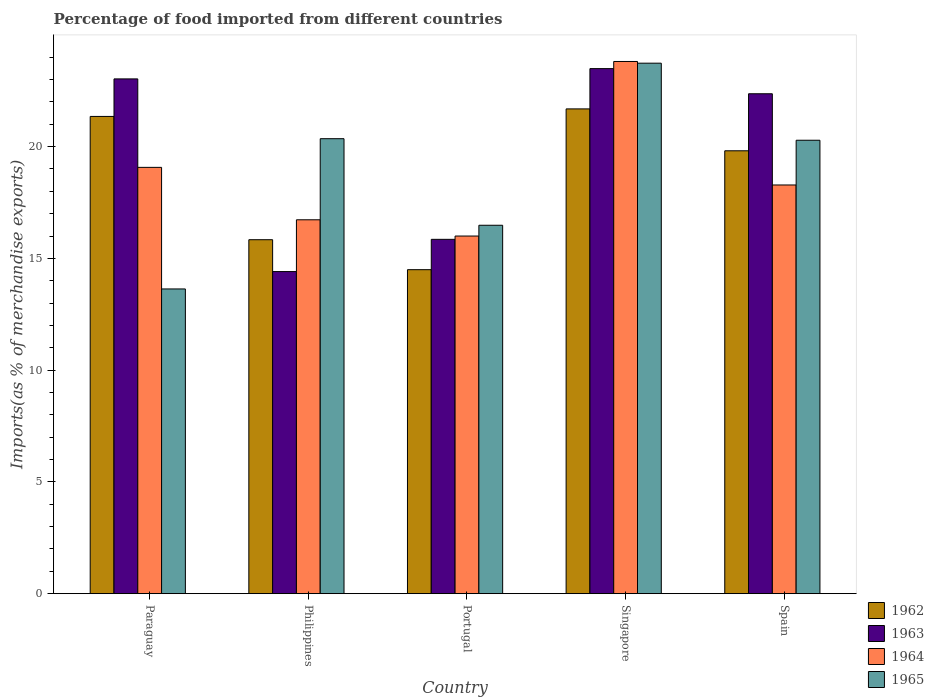How many different coloured bars are there?
Your response must be concise. 4. Are the number of bars on each tick of the X-axis equal?
Your response must be concise. Yes. How many bars are there on the 4th tick from the right?
Provide a short and direct response. 4. What is the label of the 1st group of bars from the left?
Keep it short and to the point. Paraguay. In how many cases, is the number of bars for a given country not equal to the number of legend labels?
Make the answer very short. 0. What is the percentage of imports to different countries in 1964 in Singapore?
Keep it short and to the point. 23.81. Across all countries, what is the maximum percentage of imports to different countries in 1964?
Provide a short and direct response. 23.81. Across all countries, what is the minimum percentage of imports to different countries in 1963?
Offer a terse response. 14.41. In which country was the percentage of imports to different countries in 1963 maximum?
Your answer should be compact. Singapore. In which country was the percentage of imports to different countries in 1965 minimum?
Your answer should be very brief. Paraguay. What is the total percentage of imports to different countries in 1963 in the graph?
Your answer should be compact. 99.14. What is the difference between the percentage of imports to different countries in 1963 in Philippines and that in Spain?
Provide a succinct answer. -7.96. What is the difference between the percentage of imports to different countries in 1964 in Portugal and the percentage of imports to different countries in 1965 in Philippines?
Make the answer very short. -4.36. What is the average percentage of imports to different countries in 1963 per country?
Your answer should be very brief. 19.83. What is the difference between the percentage of imports to different countries of/in 1964 and percentage of imports to different countries of/in 1963 in Paraguay?
Make the answer very short. -3.96. What is the ratio of the percentage of imports to different countries in 1965 in Paraguay to that in Portugal?
Keep it short and to the point. 0.83. What is the difference between the highest and the second highest percentage of imports to different countries in 1963?
Your answer should be very brief. 0.66. What is the difference between the highest and the lowest percentage of imports to different countries in 1963?
Your response must be concise. 9.08. What does the 1st bar from the left in Philippines represents?
Your answer should be very brief. 1962. What does the 4th bar from the right in Portugal represents?
Provide a short and direct response. 1962. Is it the case that in every country, the sum of the percentage of imports to different countries in 1963 and percentage of imports to different countries in 1965 is greater than the percentage of imports to different countries in 1964?
Provide a short and direct response. Yes. Are all the bars in the graph horizontal?
Provide a succinct answer. No. How many countries are there in the graph?
Your answer should be very brief. 5. Does the graph contain grids?
Offer a terse response. No. How many legend labels are there?
Make the answer very short. 4. What is the title of the graph?
Give a very brief answer. Percentage of food imported from different countries. What is the label or title of the Y-axis?
Provide a succinct answer. Imports(as % of merchandise exports). What is the Imports(as % of merchandise exports) in 1962 in Paraguay?
Provide a short and direct response. 21.35. What is the Imports(as % of merchandise exports) in 1963 in Paraguay?
Offer a very short reply. 23.03. What is the Imports(as % of merchandise exports) of 1964 in Paraguay?
Offer a terse response. 19.07. What is the Imports(as % of merchandise exports) in 1965 in Paraguay?
Provide a succinct answer. 13.63. What is the Imports(as % of merchandise exports) in 1962 in Philippines?
Your answer should be very brief. 15.83. What is the Imports(as % of merchandise exports) in 1963 in Philippines?
Offer a very short reply. 14.41. What is the Imports(as % of merchandise exports) of 1964 in Philippines?
Ensure brevity in your answer.  16.73. What is the Imports(as % of merchandise exports) of 1965 in Philippines?
Give a very brief answer. 20.35. What is the Imports(as % of merchandise exports) of 1962 in Portugal?
Provide a short and direct response. 14.49. What is the Imports(as % of merchandise exports) of 1963 in Portugal?
Give a very brief answer. 15.85. What is the Imports(as % of merchandise exports) of 1964 in Portugal?
Ensure brevity in your answer.  16. What is the Imports(as % of merchandise exports) in 1965 in Portugal?
Offer a terse response. 16.48. What is the Imports(as % of merchandise exports) of 1962 in Singapore?
Provide a succinct answer. 21.69. What is the Imports(as % of merchandise exports) of 1963 in Singapore?
Make the answer very short. 23.49. What is the Imports(as % of merchandise exports) in 1964 in Singapore?
Offer a terse response. 23.81. What is the Imports(as % of merchandise exports) of 1965 in Singapore?
Give a very brief answer. 23.73. What is the Imports(as % of merchandise exports) of 1962 in Spain?
Offer a terse response. 19.81. What is the Imports(as % of merchandise exports) in 1963 in Spain?
Provide a short and direct response. 22.36. What is the Imports(as % of merchandise exports) in 1964 in Spain?
Offer a very short reply. 18.28. What is the Imports(as % of merchandise exports) in 1965 in Spain?
Provide a short and direct response. 20.28. Across all countries, what is the maximum Imports(as % of merchandise exports) of 1962?
Offer a very short reply. 21.69. Across all countries, what is the maximum Imports(as % of merchandise exports) of 1963?
Make the answer very short. 23.49. Across all countries, what is the maximum Imports(as % of merchandise exports) of 1964?
Provide a succinct answer. 23.81. Across all countries, what is the maximum Imports(as % of merchandise exports) of 1965?
Make the answer very short. 23.73. Across all countries, what is the minimum Imports(as % of merchandise exports) in 1962?
Offer a terse response. 14.49. Across all countries, what is the minimum Imports(as % of merchandise exports) in 1963?
Offer a very short reply. 14.41. Across all countries, what is the minimum Imports(as % of merchandise exports) in 1964?
Ensure brevity in your answer.  16. Across all countries, what is the minimum Imports(as % of merchandise exports) of 1965?
Provide a short and direct response. 13.63. What is the total Imports(as % of merchandise exports) in 1962 in the graph?
Your answer should be very brief. 93.18. What is the total Imports(as % of merchandise exports) in 1963 in the graph?
Ensure brevity in your answer.  99.14. What is the total Imports(as % of merchandise exports) of 1964 in the graph?
Your answer should be compact. 93.89. What is the total Imports(as % of merchandise exports) of 1965 in the graph?
Your response must be concise. 94.48. What is the difference between the Imports(as % of merchandise exports) of 1962 in Paraguay and that in Philippines?
Ensure brevity in your answer.  5.52. What is the difference between the Imports(as % of merchandise exports) in 1963 in Paraguay and that in Philippines?
Give a very brief answer. 8.62. What is the difference between the Imports(as % of merchandise exports) in 1964 in Paraguay and that in Philippines?
Provide a succinct answer. 2.35. What is the difference between the Imports(as % of merchandise exports) of 1965 in Paraguay and that in Philippines?
Provide a succinct answer. -6.72. What is the difference between the Imports(as % of merchandise exports) of 1962 in Paraguay and that in Portugal?
Provide a succinct answer. 6.86. What is the difference between the Imports(as % of merchandise exports) of 1963 in Paraguay and that in Portugal?
Offer a very short reply. 7.18. What is the difference between the Imports(as % of merchandise exports) of 1964 in Paraguay and that in Portugal?
Offer a very short reply. 3.07. What is the difference between the Imports(as % of merchandise exports) in 1965 in Paraguay and that in Portugal?
Your answer should be compact. -2.85. What is the difference between the Imports(as % of merchandise exports) in 1962 in Paraguay and that in Singapore?
Offer a very short reply. -0.34. What is the difference between the Imports(as % of merchandise exports) of 1963 in Paraguay and that in Singapore?
Keep it short and to the point. -0.46. What is the difference between the Imports(as % of merchandise exports) in 1964 in Paraguay and that in Singapore?
Your response must be concise. -4.74. What is the difference between the Imports(as % of merchandise exports) of 1965 in Paraguay and that in Singapore?
Give a very brief answer. -10.1. What is the difference between the Imports(as % of merchandise exports) of 1962 in Paraguay and that in Spain?
Offer a terse response. 1.54. What is the difference between the Imports(as % of merchandise exports) of 1963 in Paraguay and that in Spain?
Your response must be concise. 0.66. What is the difference between the Imports(as % of merchandise exports) of 1964 in Paraguay and that in Spain?
Ensure brevity in your answer.  0.79. What is the difference between the Imports(as % of merchandise exports) in 1965 in Paraguay and that in Spain?
Your answer should be very brief. -6.65. What is the difference between the Imports(as % of merchandise exports) in 1962 in Philippines and that in Portugal?
Your response must be concise. 1.34. What is the difference between the Imports(as % of merchandise exports) of 1963 in Philippines and that in Portugal?
Offer a terse response. -1.44. What is the difference between the Imports(as % of merchandise exports) in 1964 in Philippines and that in Portugal?
Give a very brief answer. 0.73. What is the difference between the Imports(as % of merchandise exports) of 1965 in Philippines and that in Portugal?
Give a very brief answer. 3.87. What is the difference between the Imports(as % of merchandise exports) in 1962 in Philippines and that in Singapore?
Provide a succinct answer. -5.85. What is the difference between the Imports(as % of merchandise exports) of 1963 in Philippines and that in Singapore?
Offer a very short reply. -9.08. What is the difference between the Imports(as % of merchandise exports) in 1964 in Philippines and that in Singapore?
Provide a succinct answer. -7.08. What is the difference between the Imports(as % of merchandise exports) of 1965 in Philippines and that in Singapore?
Offer a very short reply. -3.38. What is the difference between the Imports(as % of merchandise exports) of 1962 in Philippines and that in Spain?
Your answer should be very brief. -3.98. What is the difference between the Imports(as % of merchandise exports) of 1963 in Philippines and that in Spain?
Your answer should be compact. -7.96. What is the difference between the Imports(as % of merchandise exports) in 1964 in Philippines and that in Spain?
Offer a terse response. -1.56. What is the difference between the Imports(as % of merchandise exports) in 1965 in Philippines and that in Spain?
Provide a succinct answer. 0.07. What is the difference between the Imports(as % of merchandise exports) in 1962 in Portugal and that in Singapore?
Give a very brief answer. -7.19. What is the difference between the Imports(as % of merchandise exports) of 1963 in Portugal and that in Singapore?
Your response must be concise. -7.64. What is the difference between the Imports(as % of merchandise exports) of 1964 in Portugal and that in Singapore?
Offer a very short reply. -7.81. What is the difference between the Imports(as % of merchandise exports) in 1965 in Portugal and that in Singapore?
Provide a short and direct response. -7.25. What is the difference between the Imports(as % of merchandise exports) in 1962 in Portugal and that in Spain?
Provide a succinct answer. -5.32. What is the difference between the Imports(as % of merchandise exports) in 1963 in Portugal and that in Spain?
Offer a very short reply. -6.51. What is the difference between the Imports(as % of merchandise exports) of 1964 in Portugal and that in Spain?
Make the answer very short. -2.28. What is the difference between the Imports(as % of merchandise exports) of 1965 in Portugal and that in Spain?
Your response must be concise. -3.8. What is the difference between the Imports(as % of merchandise exports) of 1962 in Singapore and that in Spain?
Your response must be concise. 1.87. What is the difference between the Imports(as % of merchandise exports) of 1963 in Singapore and that in Spain?
Ensure brevity in your answer.  1.12. What is the difference between the Imports(as % of merchandise exports) in 1964 in Singapore and that in Spain?
Your response must be concise. 5.52. What is the difference between the Imports(as % of merchandise exports) of 1965 in Singapore and that in Spain?
Your response must be concise. 3.45. What is the difference between the Imports(as % of merchandise exports) in 1962 in Paraguay and the Imports(as % of merchandise exports) in 1963 in Philippines?
Offer a terse response. 6.94. What is the difference between the Imports(as % of merchandise exports) of 1962 in Paraguay and the Imports(as % of merchandise exports) of 1964 in Philippines?
Your answer should be compact. 4.62. What is the difference between the Imports(as % of merchandise exports) in 1962 in Paraguay and the Imports(as % of merchandise exports) in 1965 in Philippines?
Your answer should be compact. 1. What is the difference between the Imports(as % of merchandise exports) of 1963 in Paraguay and the Imports(as % of merchandise exports) of 1964 in Philippines?
Make the answer very short. 6.3. What is the difference between the Imports(as % of merchandise exports) in 1963 in Paraguay and the Imports(as % of merchandise exports) in 1965 in Philippines?
Your answer should be very brief. 2.67. What is the difference between the Imports(as % of merchandise exports) of 1964 in Paraguay and the Imports(as % of merchandise exports) of 1965 in Philippines?
Your answer should be compact. -1.28. What is the difference between the Imports(as % of merchandise exports) in 1962 in Paraguay and the Imports(as % of merchandise exports) in 1963 in Portugal?
Provide a short and direct response. 5.5. What is the difference between the Imports(as % of merchandise exports) of 1962 in Paraguay and the Imports(as % of merchandise exports) of 1964 in Portugal?
Your response must be concise. 5.35. What is the difference between the Imports(as % of merchandise exports) of 1962 in Paraguay and the Imports(as % of merchandise exports) of 1965 in Portugal?
Your response must be concise. 4.87. What is the difference between the Imports(as % of merchandise exports) in 1963 in Paraguay and the Imports(as % of merchandise exports) in 1964 in Portugal?
Your answer should be very brief. 7.03. What is the difference between the Imports(as % of merchandise exports) of 1963 in Paraguay and the Imports(as % of merchandise exports) of 1965 in Portugal?
Your answer should be compact. 6.55. What is the difference between the Imports(as % of merchandise exports) in 1964 in Paraguay and the Imports(as % of merchandise exports) in 1965 in Portugal?
Make the answer very short. 2.59. What is the difference between the Imports(as % of merchandise exports) in 1962 in Paraguay and the Imports(as % of merchandise exports) in 1963 in Singapore?
Your answer should be compact. -2.14. What is the difference between the Imports(as % of merchandise exports) in 1962 in Paraguay and the Imports(as % of merchandise exports) in 1964 in Singapore?
Your answer should be compact. -2.46. What is the difference between the Imports(as % of merchandise exports) in 1962 in Paraguay and the Imports(as % of merchandise exports) in 1965 in Singapore?
Your answer should be compact. -2.38. What is the difference between the Imports(as % of merchandise exports) in 1963 in Paraguay and the Imports(as % of merchandise exports) in 1964 in Singapore?
Give a very brief answer. -0.78. What is the difference between the Imports(as % of merchandise exports) in 1963 in Paraguay and the Imports(as % of merchandise exports) in 1965 in Singapore?
Provide a short and direct response. -0.7. What is the difference between the Imports(as % of merchandise exports) of 1964 in Paraguay and the Imports(as % of merchandise exports) of 1965 in Singapore?
Keep it short and to the point. -4.66. What is the difference between the Imports(as % of merchandise exports) in 1962 in Paraguay and the Imports(as % of merchandise exports) in 1963 in Spain?
Offer a very short reply. -1.01. What is the difference between the Imports(as % of merchandise exports) of 1962 in Paraguay and the Imports(as % of merchandise exports) of 1964 in Spain?
Offer a very short reply. 3.07. What is the difference between the Imports(as % of merchandise exports) in 1962 in Paraguay and the Imports(as % of merchandise exports) in 1965 in Spain?
Provide a short and direct response. 1.07. What is the difference between the Imports(as % of merchandise exports) in 1963 in Paraguay and the Imports(as % of merchandise exports) in 1964 in Spain?
Provide a succinct answer. 4.75. What is the difference between the Imports(as % of merchandise exports) of 1963 in Paraguay and the Imports(as % of merchandise exports) of 1965 in Spain?
Provide a short and direct response. 2.74. What is the difference between the Imports(as % of merchandise exports) in 1964 in Paraguay and the Imports(as % of merchandise exports) in 1965 in Spain?
Provide a succinct answer. -1.21. What is the difference between the Imports(as % of merchandise exports) in 1962 in Philippines and the Imports(as % of merchandise exports) in 1963 in Portugal?
Your response must be concise. -0.02. What is the difference between the Imports(as % of merchandise exports) of 1962 in Philippines and the Imports(as % of merchandise exports) of 1964 in Portugal?
Make the answer very short. -0.16. What is the difference between the Imports(as % of merchandise exports) in 1962 in Philippines and the Imports(as % of merchandise exports) in 1965 in Portugal?
Offer a very short reply. -0.65. What is the difference between the Imports(as % of merchandise exports) of 1963 in Philippines and the Imports(as % of merchandise exports) of 1964 in Portugal?
Offer a terse response. -1.59. What is the difference between the Imports(as % of merchandise exports) in 1963 in Philippines and the Imports(as % of merchandise exports) in 1965 in Portugal?
Keep it short and to the point. -2.07. What is the difference between the Imports(as % of merchandise exports) in 1964 in Philippines and the Imports(as % of merchandise exports) in 1965 in Portugal?
Your response must be concise. 0.24. What is the difference between the Imports(as % of merchandise exports) in 1962 in Philippines and the Imports(as % of merchandise exports) in 1963 in Singapore?
Make the answer very short. -7.65. What is the difference between the Imports(as % of merchandise exports) in 1962 in Philippines and the Imports(as % of merchandise exports) in 1964 in Singapore?
Your response must be concise. -7.97. What is the difference between the Imports(as % of merchandise exports) of 1962 in Philippines and the Imports(as % of merchandise exports) of 1965 in Singapore?
Offer a very short reply. -7.9. What is the difference between the Imports(as % of merchandise exports) of 1963 in Philippines and the Imports(as % of merchandise exports) of 1964 in Singapore?
Provide a short and direct response. -9.4. What is the difference between the Imports(as % of merchandise exports) in 1963 in Philippines and the Imports(as % of merchandise exports) in 1965 in Singapore?
Your response must be concise. -9.32. What is the difference between the Imports(as % of merchandise exports) of 1964 in Philippines and the Imports(as % of merchandise exports) of 1965 in Singapore?
Your answer should be compact. -7.01. What is the difference between the Imports(as % of merchandise exports) of 1962 in Philippines and the Imports(as % of merchandise exports) of 1963 in Spain?
Ensure brevity in your answer.  -6.53. What is the difference between the Imports(as % of merchandise exports) in 1962 in Philippines and the Imports(as % of merchandise exports) in 1964 in Spain?
Keep it short and to the point. -2.45. What is the difference between the Imports(as % of merchandise exports) in 1962 in Philippines and the Imports(as % of merchandise exports) in 1965 in Spain?
Offer a very short reply. -4.45. What is the difference between the Imports(as % of merchandise exports) of 1963 in Philippines and the Imports(as % of merchandise exports) of 1964 in Spain?
Your answer should be compact. -3.87. What is the difference between the Imports(as % of merchandise exports) in 1963 in Philippines and the Imports(as % of merchandise exports) in 1965 in Spain?
Keep it short and to the point. -5.88. What is the difference between the Imports(as % of merchandise exports) of 1964 in Philippines and the Imports(as % of merchandise exports) of 1965 in Spain?
Make the answer very short. -3.56. What is the difference between the Imports(as % of merchandise exports) in 1962 in Portugal and the Imports(as % of merchandise exports) in 1963 in Singapore?
Offer a very short reply. -8.99. What is the difference between the Imports(as % of merchandise exports) in 1962 in Portugal and the Imports(as % of merchandise exports) in 1964 in Singapore?
Provide a short and direct response. -9.31. What is the difference between the Imports(as % of merchandise exports) of 1962 in Portugal and the Imports(as % of merchandise exports) of 1965 in Singapore?
Keep it short and to the point. -9.24. What is the difference between the Imports(as % of merchandise exports) in 1963 in Portugal and the Imports(as % of merchandise exports) in 1964 in Singapore?
Make the answer very short. -7.96. What is the difference between the Imports(as % of merchandise exports) in 1963 in Portugal and the Imports(as % of merchandise exports) in 1965 in Singapore?
Offer a terse response. -7.88. What is the difference between the Imports(as % of merchandise exports) in 1964 in Portugal and the Imports(as % of merchandise exports) in 1965 in Singapore?
Provide a succinct answer. -7.73. What is the difference between the Imports(as % of merchandise exports) in 1962 in Portugal and the Imports(as % of merchandise exports) in 1963 in Spain?
Your response must be concise. -7.87. What is the difference between the Imports(as % of merchandise exports) of 1962 in Portugal and the Imports(as % of merchandise exports) of 1964 in Spain?
Your response must be concise. -3.79. What is the difference between the Imports(as % of merchandise exports) in 1962 in Portugal and the Imports(as % of merchandise exports) in 1965 in Spain?
Offer a very short reply. -5.79. What is the difference between the Imports(as % of merchandise exports) in 1963 in Portugal and the Imports(as % of merchandise exports) in 1964 in Spain?
Your answer should be very brief. -2.43. What is the difference between the Imports(as % of merchandise exports) in 1963 in Portugal and the Imports(as % of merchandise exports) in 1965 in Spain?
Give a very brief answer. -4.43. What is the difference between the Imports(as % of merchandise exports) of 1964 in Portugal and the Imports(as % of merchandise exports) of 1965 in Spain?
Ensure brevity in your answer.  -4.29. What is the difference between the Imports(as % of merchandise exports) in 1962 in Singapore and the Imports(as % of merchandise exports) in 1963 in Spain?
Your answer should be very brief. -0.68. What is the difference between the Imports(as % of merchandise exports) of 1962 in Singapore and the Imports(as % of merchandise exports) of 1964 in Spain?
Make the answer very short. 3.4. What is the difference between the Imports(as % of merchandise exports) in 1962 in Singapore and the Imports(as % of merchandise exports) in 1965 in Spain?
Keep it short and to the point. 1.4. What is the difference between the Imports(as % of merchandise exports) of 1963 in Singapore and the Imports(as % of merchandise exports) of 1964 in Spain?
Keep it short and to the point. 5.21. What is the difference between the Imports(as % of merchandise exports) in 1963 in Singapore and the Imports(as % of merchandise exports) in 1965 in Spain?
Your answer should be compact. 3.2. What is the difference between the Imports(as % of merchandise exports) in 1964 in Singapore and the Imports(as % of merchandise exports) in 1965 in Spain?
Make the answer very short. 3.52. What is the average Imports(as % of merchandise exports) in 1962 per country?
Offer a terse response. 18.64. What is the average Imports(as % of merchandise exports) of 1963 per country?
Keep it short and to the point. 19.83. What is the average Imports(as % of merchandise exports) of 1964 per country?
Your answer should be compact. 18.78. What is the average Imports(as % of merchandise exports) of 1965 per country?
Your answer should be compact. 18.9. What is the difference between the Imports(as % of merchandise exports) in 1962 and Imports(as % of merchandise exports) in 1963 in Paraguay?
Provide a succinct answer. -1.68. What is the difference between the Imports(as % of merchandise exports) of 1962 and Imports(as % of merchandise exports) of 1964 in Paraguay?
Your answer should be compact. 2.28. What is the difference between the Imports(as % of merchandise exports) of 1962 and Imports(as % of merchandise exports) of 1965 in Paraguay?
Provide a short and direct response. 7.72. What is the difference between the Imports(as % of merchandise exports) of 1963 and Imports(as % of merchandise exports) of 1964 in Paraguay?
Your answer should be compact. 3.96. What is the difference between the Imports(as % of merchandise exports) of 1963 and Imports(as % of merchandise exports) of 1965 in Paraguay?
Offer a terse response. 9.4. What is the difference between the Imports(as % of merchandise exports) in 1964 and Imports(as % of merchandise exports) in 1965 in Paraguay?
Provide a succinct answer. 5.44. What is the difference between the Imports(as % of merchandise exports) in 1962 and Imports(as % of merchandise exports) in 1963 in Philippines?
Your answer should be compact. 1.43. What is the difference between the Imports(as % of merchandise exports) in 1962 and Imports(as % of merchandise exports) in 1964 in Philippines?
Make the answer very short. -0.89. What is the difference between the Imports(as % of merchandise exports) in 1962 and Imports(as % of merchandise exports) in 1965 in Philippines?
Keep it short and to the point. -4.52. What is the difference between the Imports(as % of merchandise exports) in 1963 and Imports(as % of merchandise exports) in 1964 in Philippines?
Offer a very short reply. -2.32. What is the difference between the Imports(as % of merchandise exports) in 1963 and Imports(as % of merchandise exports) in 1965 in Philippines?
Ensure brevity in your answer.  -5.94. What is the difference between the Imports(as % of merchandise exports) in 1964 and Imports(as % of merchandise exports) in 1965 in Philippines?
Your answer should be compact. -3.63. What is the difference between the Imports(as % of merchandise exports) of 1962 and Imports(as % of merchandise exports) of 1963 in Portugal?
Ensure brevity in your answer.  -1.36. What is the difference between the Imports(as % of merchandise exports) in 1962 and Imports(as % of merchandise exports) in 1964 in Portugal?
Your answer should be very brief. -1.5. What is the difference between the Imports(as % of merchandise exports) in 1962 and Imports(as % of merchandise exports) in 1965 in Portugal?
Offer a very short reply. -1.99. What is the difference between the Imports(as % of merchandise exports) of 1963 and Imports(as % of merchandise exports) of 1964 in Portugal?
Your response must be concise. -0.15. What is the difference between the Imports(as % of merchandise exports) in 1963 and Imports(as % of merchandise exports) in 1965 in Portugal?
Make the answer very short. -0.63. What is the difference between the Imports(as % of merchandise exports) in 1964 and Imports(as % of merchandise exports) in 1965 in Portugal?
Offer a terse response. -0.48. What is the difference between the Imports(as % of merchandise exports) of 1962 and Imports(as % of merchandise exports) of 1963 in Singapore?
Make the answer very short. -1.8. What is the difference between the Imports(as % of merchandise exports) of 1962 and Imports(as % of merchandise exports) of 1964 in Singapore?
Give a very brief answer. -2.12. What is the difference between the Imports(as % of merchandise exports) in 1962 and Imports(as % of merchandise exports) in 1965 in Singapore?
Offer a very short reply. -2.04. What is the difference between the Imports(as % of merchandise exports) of 1963 and Imports(as % of merchandise exports) of 1964 in Singapore?
Offer a terse response. -0.32. What is the difference between the Imports(as % of merchandise exports) in 1963 and Imports(as % of merchandise exports) in 1965 in Singapore?
Make the answer very short. -0.24. What is the difference between the Imports(as % of merchandise exports) of 1964 and Imports(as % of merchandise exports) of 1965 in Singapore?
Offer a terse response. 0.08. What is the difference between the Imports(as % of merchandise exports) of 1962 and Imports(as % of merchandise exports) of 1963 in Spain?
Your response must be concise. -2.55. What is the difference between the Imports(as % of merchandise exports) in 1962 and Imports(as % of merchandise exports) in 1964 in Spain?
Provide a succinct answer. 1.53. What is the difference between the Imports(as % of merchandise exports) in 1962 and Imports(as % of merchandise exports) in 1965 in Spain?
Make the answer very short. -0.47. What is the difference between the Imports(as % of merchandise exports) of 1963 and Imports(as % of merchandise exports) of 1964 in Spain?
Your answer should be compact. 4.08. What is the difference between the Imports(as % of merchandise exports) of 1963 and Imports(as % of merchandise exports) of 1965 in Spain?
Your answer should be compact. 2.08. What is the difference between the Imports(as % of merchandise exports) in 1964 and Imports(as % of merchandise exports) in 1965 in Spain?
Provide a succinct answer. -2. What is the ratio of the Imports(as % of merchandise exports) in 1962 in Paraguay to that in Philippines?
Your answer should be very brief. 1.35. What is the ratio of the Imports(as % of merchandise exports) in 1963 in Paraguay to that in Philippines?
Make the answer very short. 1.6. What is the ratio of the Imports(as % of merchandise exports) in 1964 in Paraguay to that in Philippines?
Ensure brevity in your answer.  1.14. What is the ratio of the Imports(as % of merchandise exports) of 1965 in Paraguay to that in Philippines?
Provide a succinct answer. 0.67. What is the ratio of the Imports(as % of merchandise exports) of 1962 in Paraguay to that in Portugal?
Your answer should be compact. 1.47. What is the ratio of the Imports(as % of merchandise exports) in 1963 in Paraguay to that in Portugal?
Your answer should be very brief. 1.45. What is the ratio of the Imports(as % of merchandise exports) in 1964 in Paraguay to that in Portugal?
Offer a very short reply. 1.19. What is the ratio of the Imports(as % of merchandise exports) in 1965 in Paraguay to that in Portugal?
Your response must be concise. 0.83. What is the ratio of the Imports(as % of merchandise exports) in 1962 in Paraguay to that in Singapore?
Provide a succinct answer. 0.98. What is the ratio of the Imports(as % of merchandise exports) of 1963 in Paraguay to that in Singapore?
Your answer should be very brief. 0.98. What is the ratio of the Imports(as % of merchandise exports) in 1964 in Paraguay to that in Singapore?
Give a very brief answer. 0.8. What is the ratio of the Imports(as % of merchandise exports) of 1965 in Paraguay to that in Singapore?
Provide a short and direct response. 0.57. What is the ratio of the Imports(as % of merchandise exports) in 1962 in Paraguay to that in Spain?
Your answer should be very brief. 1.08. What is the ratio of the Imports(as % of merchandise exports) in 1963 in Paraguay to that in Spain?
Your answer should be very brief. 1.03. What is the ratio of the Imports(as % of merchandise exports) in 1964 in Paraguay to that in Spain?
Offer a terse response. 1.04. What is the ratio of the Imports(as % of merchandise exports) of 1965 in Paraguay to that in Spain?
Offer a terse response. 0.67. What is the ratio of the Imports(as % of merchandise exports) of 1962 in Philippines to that in Portugal?
Give a very brief answer. 1.09. What is the ratio of the Imports(as % of merchandise exports) of 1963 in Philippines to that in Portugal?
Offer a very short reply. 0.91. What is the ratio of the Imports(as % of merchandise exports) in 1964 in Philippines to that in Portugal?
Give a very brief answer. 1.05. What is the ratio of the Imports(as % of merchandise exports) of 1965 in Philippines to that in Portugal?
Keep it short and to the point. 1.24. What is the ratio of the Imports(as % of merchandise exports) of 1962 in Philippines to that in Singapore?
Your response must be concise. 0.73. What is the ratio of the Imports(as % of merchandise exports) of 1963 in Philippines to that in Singapore?
Offer a terse response. 0.61. What is the ratio of the Imports(as % of merchandise exports) in 1964 in Philippines to that in Singapore?
Your response must be concise. 0.7. What is the ratio of the Imports(as % of merchandise exports) in 1965 in Philippines to that in Singapore?
Ensure brevity in your answer.  0.86. What is the ratio of the Imports(as % of merchandise exports) of 1962 in Philippines to that in Spain?
Give a very brief answer. 0.8. What is the ratio of the Imports(as % of merchandise exports) in 1963 in Philippines to that in Spain?
Keep it short and to the point. 0.64. What is the ratio of the Imports(as % of merchandise exports) in 1964 in Philippines to that in Spain?
Offer a very short reply. 0.91. What is the ratio of the Imports(as % of merchandise exports) of 1965 in Philippines to that in Spain?
Provide a short and direct response. 1. What is the ratio of the Imports(as % of merchandise exports) in 1962 in Portugal to that in Singapore?
Your answer should be very brief. 0.67. What is the ratio of the Imports(as % of merchandise exports) in 1963 in Portugal to that in Singapore?
Your answer should be very brief. 0.67. What is the ratio of the Imports(as % of merchandise exports) in 1964 in Portugal to that in Singapore?
Give a very brief answer. 0.67. What is the ratio of the Imports(as % of merchandise exports) in 1965 in Portugal to that in Singapore?
Provide a succinct answer. 0.69. What is the ratio of the Imports(as % of merchandise exports) in 1962 in Portugal to that in Spain?
Provide a succinct answer. 0.73. What is the ratio of the Imports(as % of merchandise exports) in 1963 in Portugal to that in Spain?
Your answer should be compact. 0.71. What is the ratio of the Imports(as % of merchandise exports) in 1965 in Portugal to that in Spain?
Provide a succinct answer. 0.81. What is the ratio of the Imports(as % of merchandise exports) in 1962 in Singapore to that in Spain?
Provide a short and direct response. 1.09. What is the ratio of the Imports(as % of merchandise exports) in 1963 in Singapore to that in Spain?
Provide a short and direct response. 1.05. What is the ratio of the Imports(as % of merchandise exports) in 1964 in Singapore to that in Spain?
Provide a short and direct response. 1.3. What is the ratio of the Imports(as % of merchandise exports) in 1965 in Singapore to that in Spain?
Keep it short and to the point. 1.17. What is the difference between the highest and the second highest Imports(as % of merchandise exports) of 1962?
Offer a very short reply. 0.34. What is the difference between the highest and the second highest Imports(as % of merchandise exports) of 1963?
Keep it short and to the point. 0.46. What is the difference between the highest and the second highest Imports(as % of merchandise exports) in 1964?
Give a very brief answer. 4.74. What is the difference between the highest and the second highest Imports(as % of merchandise exports) in 1965?
Ensure brevity in your answer.  3.38. What is the difference between the highest and the lowest Imports(as % of merchandise exports) in 1962?
Ensure brevity in your answer.  7.19. What is the difference between the highest and the lowest Imports(as % of merchandise exports) in 1963?
Ensure brevity in your answer.  9.08. What is the difference between the highest and the lowest Imports(as % of merchandise exports) in 1964?
Your answer should be compact. 7.81. What is the difference between the highest and the lowest Imports(as % of merchandise exports) in 1965?
Keep it short and to the point. 10.1. 